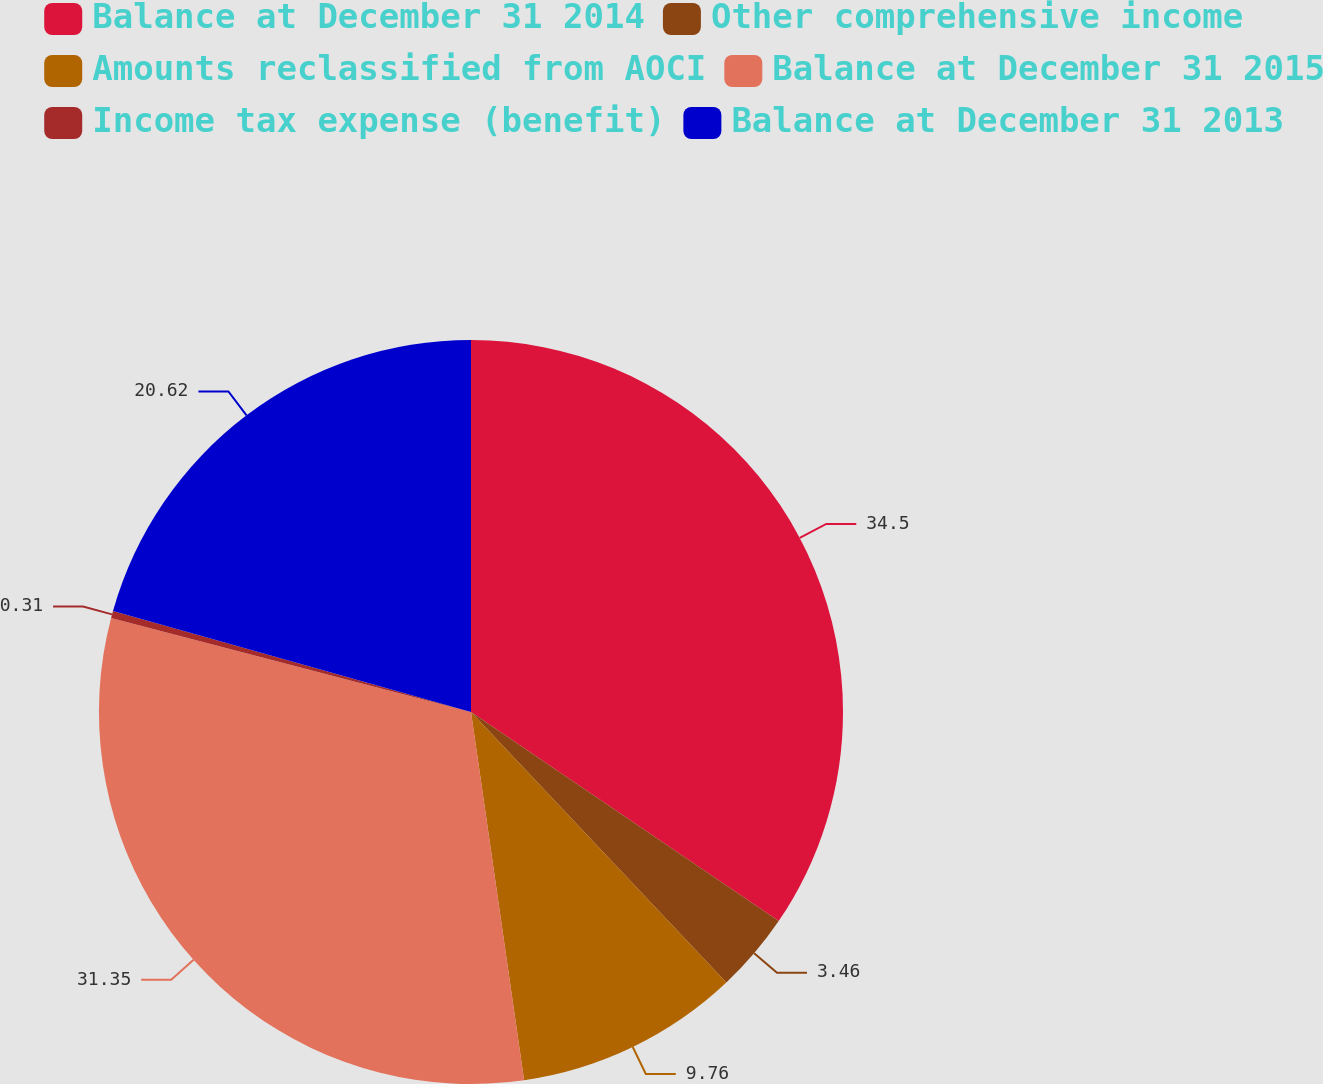Convert chart. <chart><loc_0><loc_0><loc_500><loc_500><pie_chart><fcel>Balance at December 31 2014<fcel>Other comprehensive income<fcel>Amounts reclassified from AOCI<fcel>Balance at December 31 2015<fcel>Income tax expense (benefit)<fcel>Balance at December 31 2013<nl><fcel>34.5%<fcel>3.46%<fcel>9.76%<fcel>31.35%<fcel>0.31%<fcel>20.62%<nl></chart> 